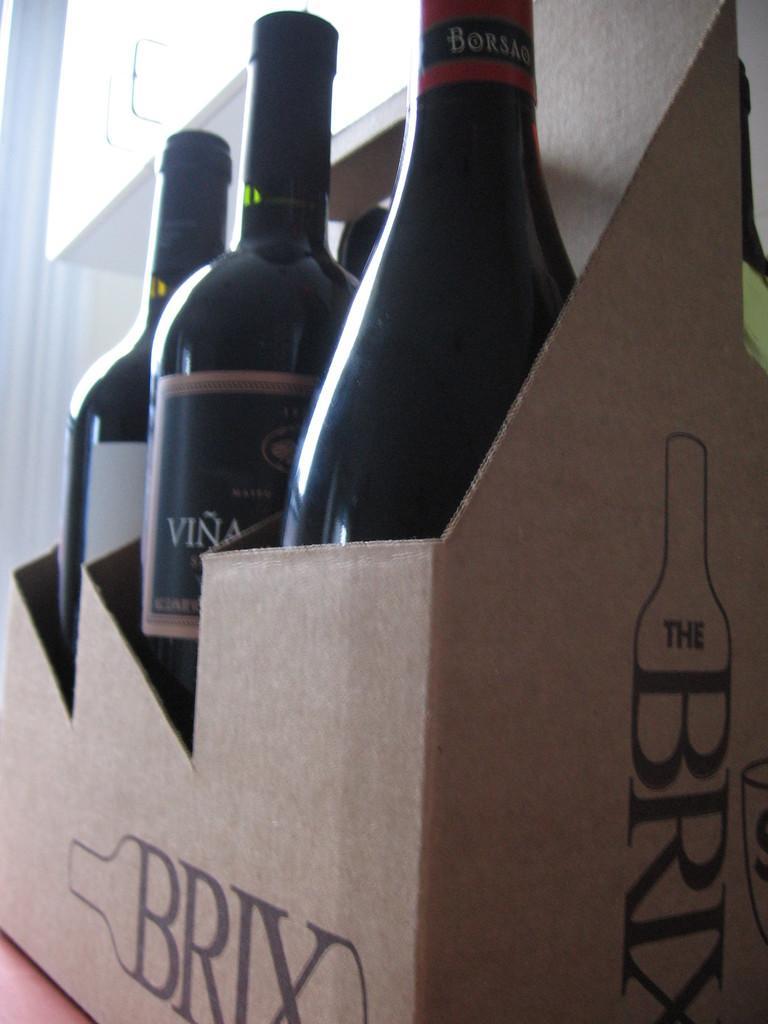Please provide a concise description of this image. In this picture I can see 3 bottles in a box and I see something is written on the box. In the background I can see the wall and I see that it is white color on the top left corner of this picture. 